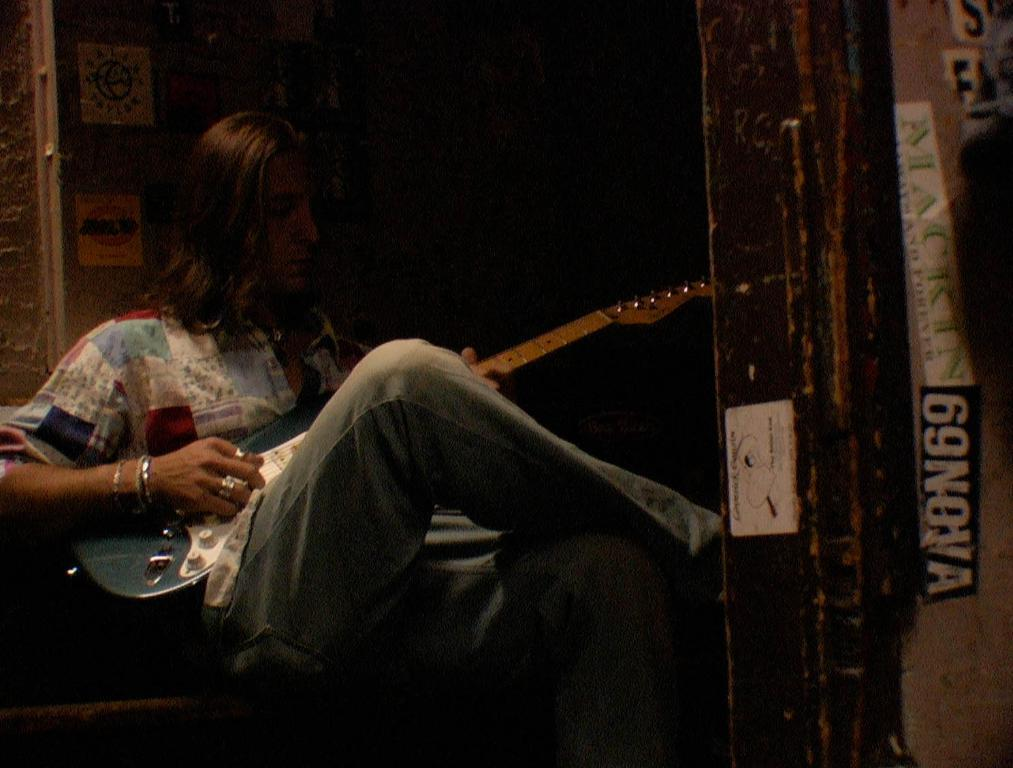<image>
Relay a brief, clear account of the picture shown. A person playing the guitar with a sticker on the door of 69Nova. 